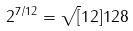Convert formula to latex. <formula><loc_0><loc_0><loc_500><loc_500>2 ^ { 7 / 1 2 } = \sqrt { [ } 1 2 ] { 1 2 8 }</formula> 